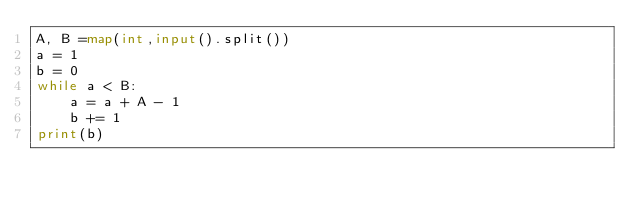<code> <loc_0><loc_0><loc_500><loc_500><_Python_>A, B =map(int,input().split())
a = 1
b = 0
while a < B:
    a = a + A - 1
    b += 1
print(b)</code> 